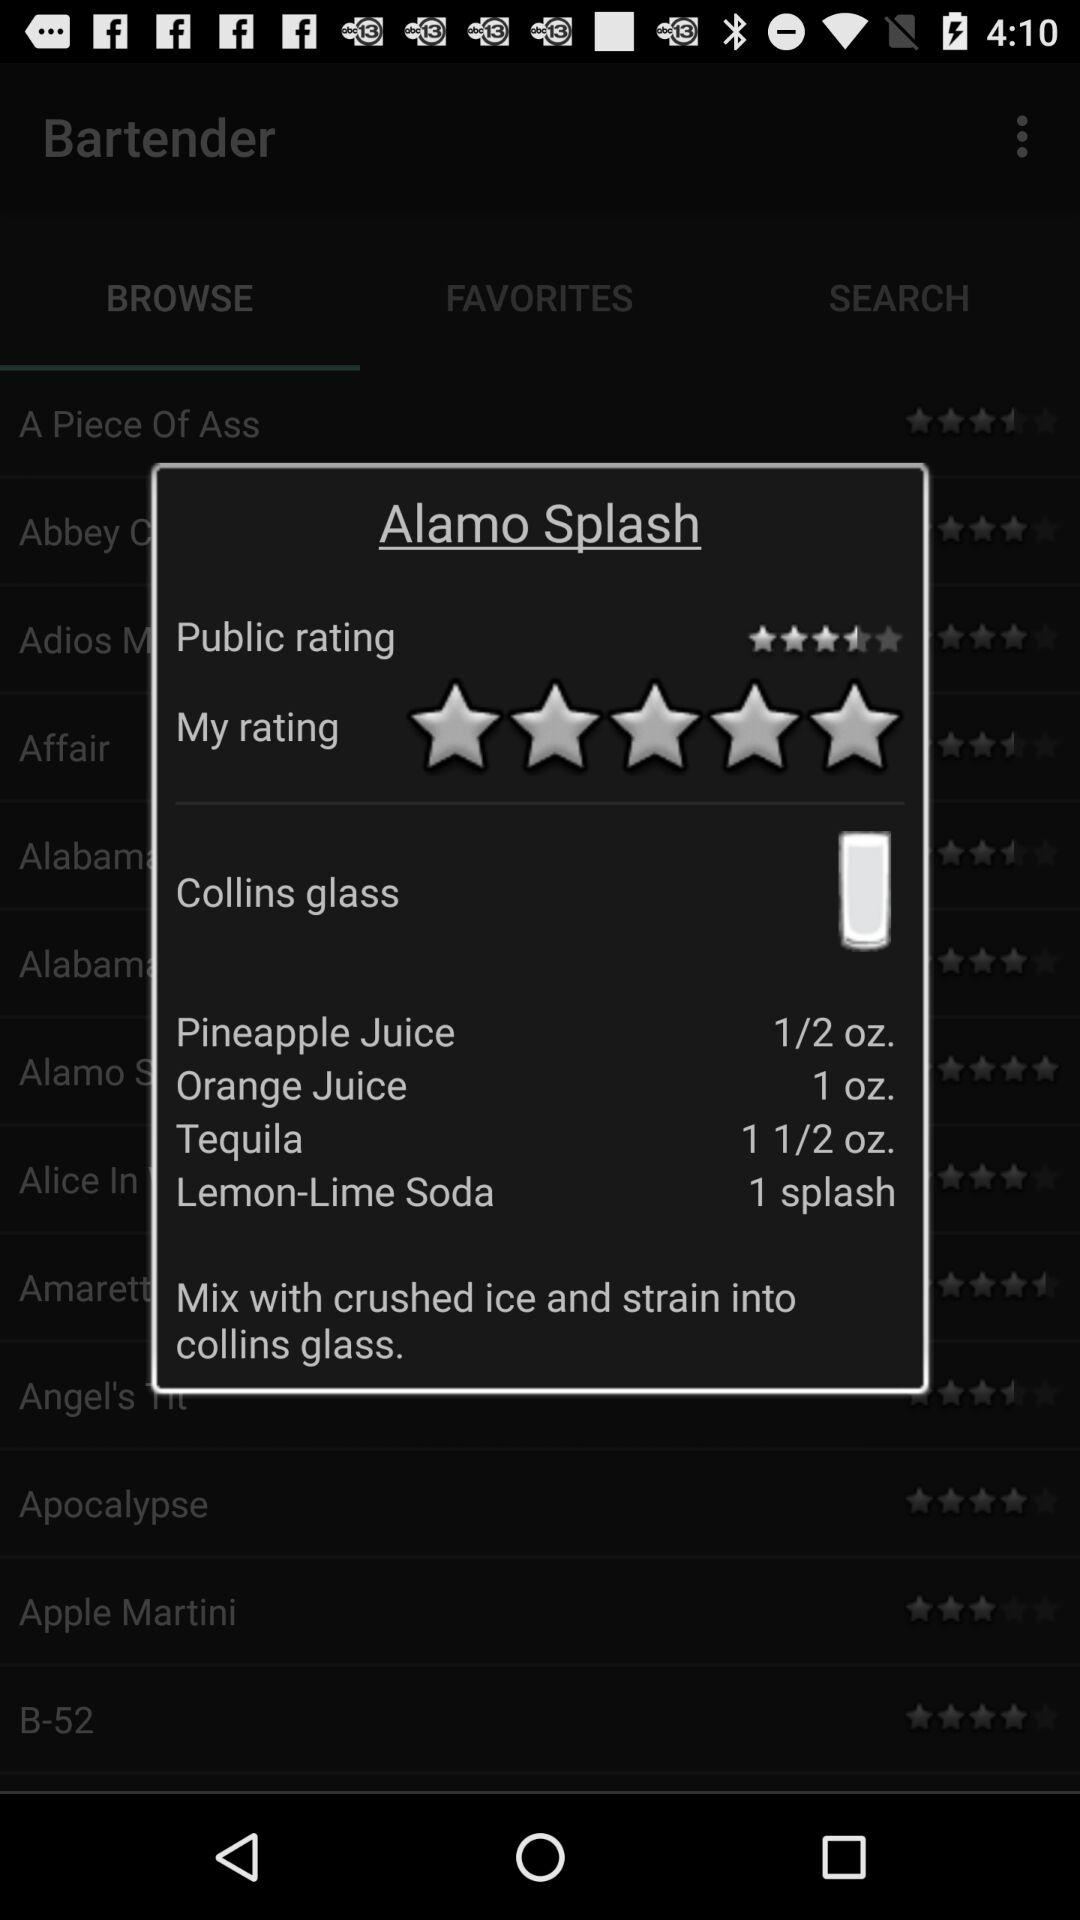How many ingredients are in the Alamo Splash?
Answer the question using a single word or phrase. 4 